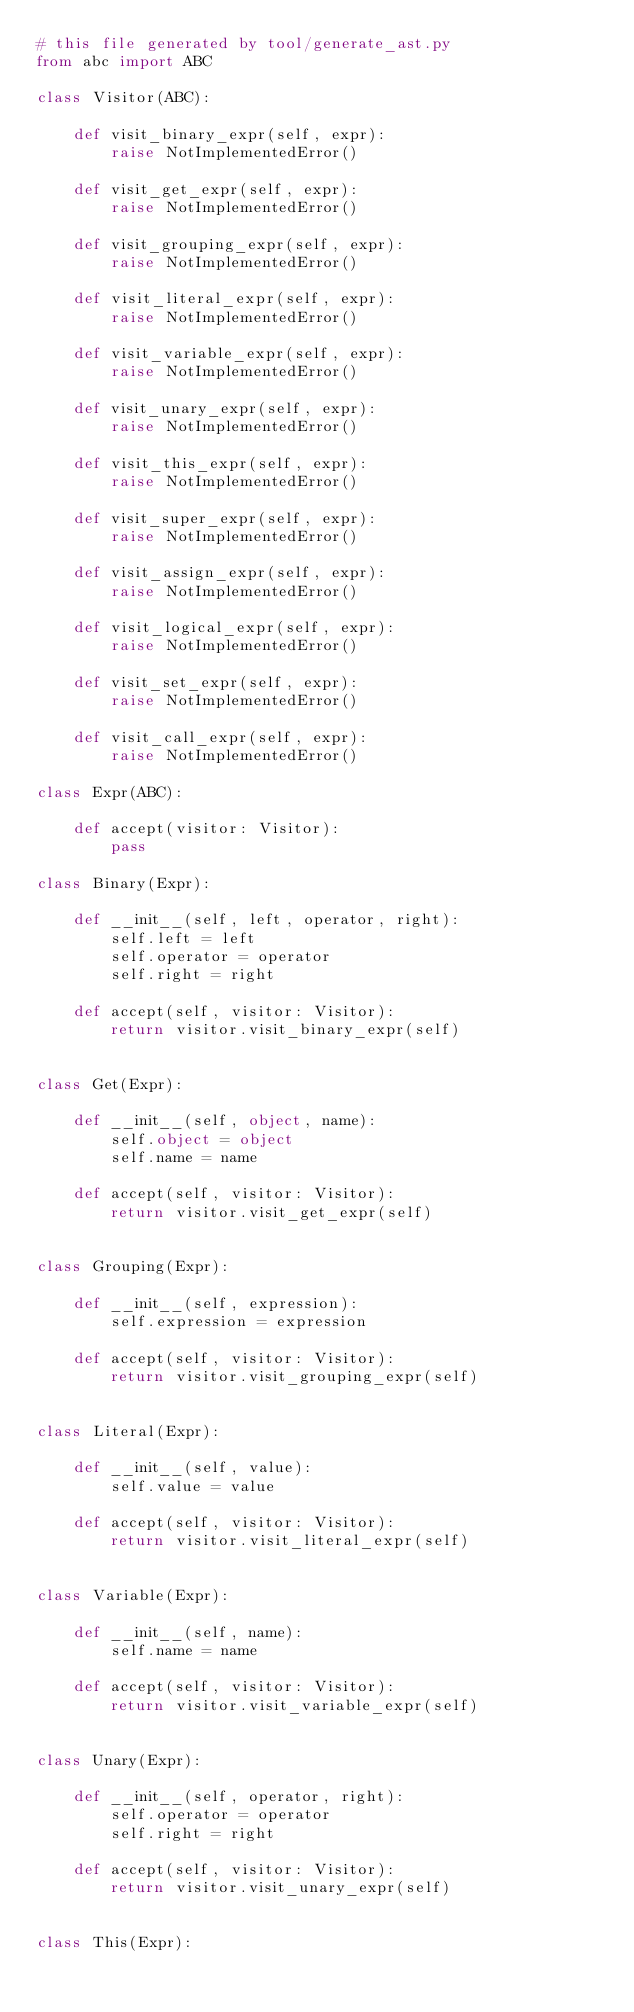<code> <loc_0><loc_0><loc_500><loc_500><_Python_># this file generated by tool/generate_ast.py
from abc import ABC

class Visitor(ABC):

    def visit_binary_expr(self, expr):
        raise NotImplementedError()

    def visit_get_expr(self, expr):
        raise NotImplementedError()

    def visit_grouping_expr(self, expr):
        raise NotImplementedError()

    def visit_literal_expr(self, expr):
        raise NotImplementedError()

    def visit_variable_expr(self, expr):
        raise NotImplementedError()

    def visit_unary_expr(self, expr):
        raise NotImplementedError()

    def visit_this_expr(self, expr):
        raise NotImplementedError()

    def visit_super_expr(self, expr):
        raise NotImplementedError()

    def visit_assign_expr(self, expr):
        raise NotImplementedError()

    def visit_logical_expr(self, expr):
        raise NotImplementedError()

    def visit_set_expr(self, expr):
        raise NotImplementedError()

    def visit_call_expr(self, expr):
        raise NotImplementedError()

class Expr(ABC):

    def accept(visitor: Visitor):
        pass

class Binary(Expr):

    def __init__(self, left, operator, right):
        self.left = left
        self.operator = operator
        self.right = right

    def accept(self, visitor: Visitor):
        return visitor.visit_binary_expr(self)


class Get(Expr):

    def __init__(self, object, name):
        self.object = object
        self.name = name

    def accept(self, visitor: Visitor):
        return visitor.visit_get_expr(self)


class Grouping(Expr):

    def __init__(self, expression):
        self.expression = expression

    def accept(self, visitor: Visitor):
        return visitor.visit_grouping_expr(self)


class Literal(Expr):

    def __init__(self, value):
        self.value = value

    def accept(self, visitor: Visitor):
        return visitor.visit_literal_expr(self)


class Variable(Expr):

    def __init__(self, name):
        self.name = name

    def accept(self, visitor: Visitor):
        return visitor.visit_variable_expr(self)


class Unary(Expr):

    def __init__(self, operator, right):
        self.operator = operator
        self.right = right

    def accept(self, visitor: Visitor):
        return visitor.visit_unary_expr(self)


class This(Expr):
</code> 